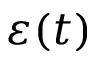<formula> <loc_0><loc_0><loc_500><loc_500>\varepsilon ( t )</formula> 